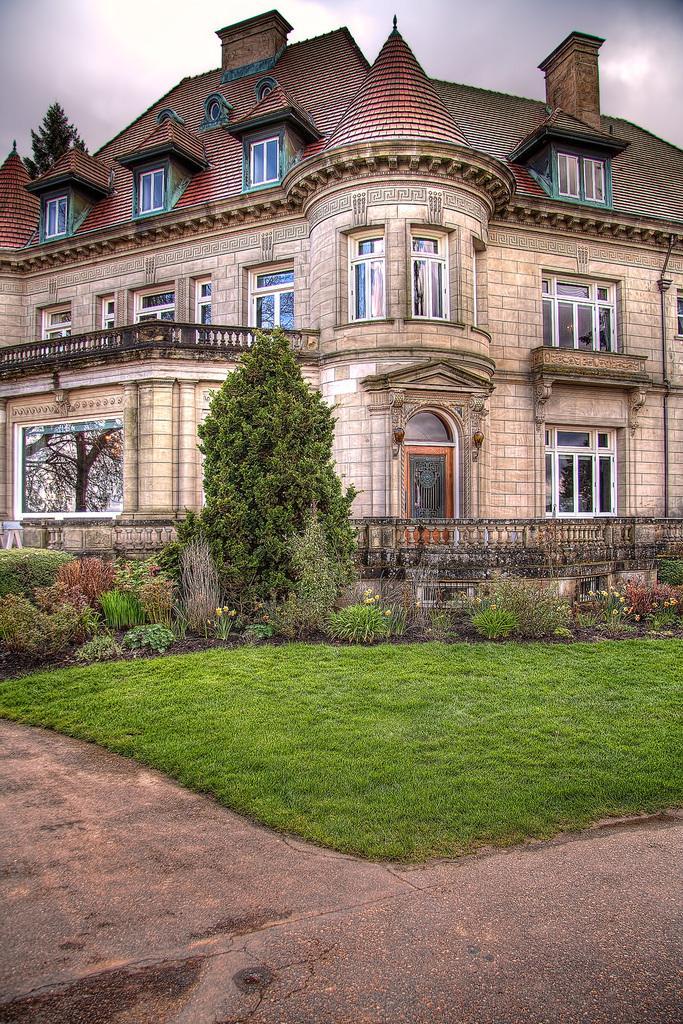Could you give a brief overview of what you see in this image? At the bottom we can see road and grass on the ground. In the background there are trees, plants, building, windows, door, roof, fence, objects and clouds in the sky. 